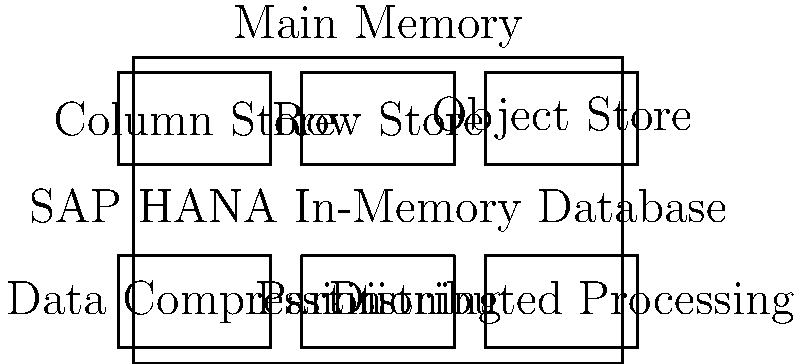Based on the diagram of SAP HANA's in-memory architecture, which component is likely to contribute most significantly to improved query performance for analytical workloads, and why? To answer this question, let's analyze the components of SAP HANA's in-memory architecture:

1. Column Store: This is the primary storage format for analytical data in SAP HANA. It organizes data by columns rather than rows, which is highly efficient for analytical queries that typically involve aggregations and scans of specific columns.

2. Row Store: This is used for transactional data and is optimized for single-record operations. It's less efficient for analytical workloads.

3. Object Store: This is used for storing large objects and unstructured data. It's not typically the primary factor in analytical query performance.

4. Data Compression: While this helps reduce memory footprint, it's not the primary driver of query performance.

5. Partitioning: This can improve performance by allowing parallel processing of data subsets, but its impact is secondary to the storage format.

6. Distributed Processing: This can enhance performance for very large datasets but is not the primary factor for most analytical queries.

The Column Store is likely to contribute most significantly to improved query performance for analytical workloads because:

a) It allows for efficient in-memory processing of large datasets.
b) It enables faster data scans and aggregations, which are common in analytical queries.
c) It reduces I/O operations by storing data in a format optimized for analytical processing.
d) It facilitates better compression ratios, allowing more data to be held in memory.

Therefore, the Column Store component is the most critical for improving analytical query performance in SAP HANA's in-memory architecture.
Answer: Column Store 